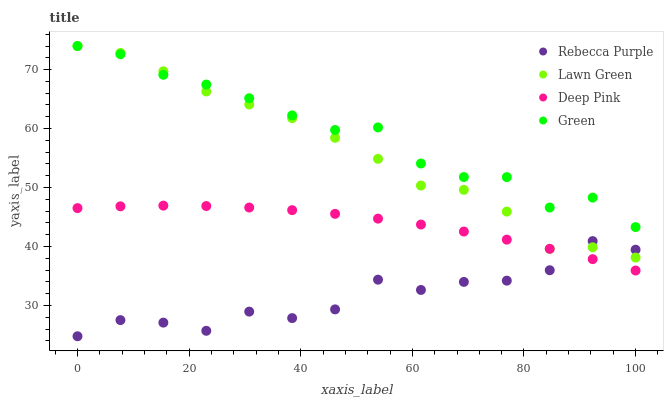Does Rebecca Purple have the minimum area under the curve?
Answer yes or no. Yes. Does Green have the maximum area under the curve?
Answer yes or no. Yes. Does Deep Pink have the minimum area under the curve?
Answer yes or no. No. Does Deep Pink have the maximum area under the curve?
Answer yes or no. No. Is Deep Pink the smoothest?
Answer yes or no. Yes. Is Rebecca Purple the roughest?
Answer yes or no. Yes. Is Green the smoothest?
Answer yes or no. No. Is Green the roughest?
Answer yes or no. No. Does Rebecca Purple have the lowest value?
Answer yes or no. Yes. Does Deep Pink have the lowest value?
Answer yes or no. No. Does Green have the highest value?
Answer yes or no. Yes. Does Deep Pink have the highest value?
Answer yes or no. No. Is Deep Pink less than Lawn Green?
Answer yes or no. Yes. Is Lawn Green greater than Deep Pink?
Answer yes or no. Yes. Does Green intersect Lawn Green?
Answer yes or no. Yes. Is Green less than Lawn Green?
Answer yes or no. No. Is Green greater than Lawn Green?
Answer yes or no. No. Does Deep Pink intersect Lawn Green?
Answer yes or no. No. 